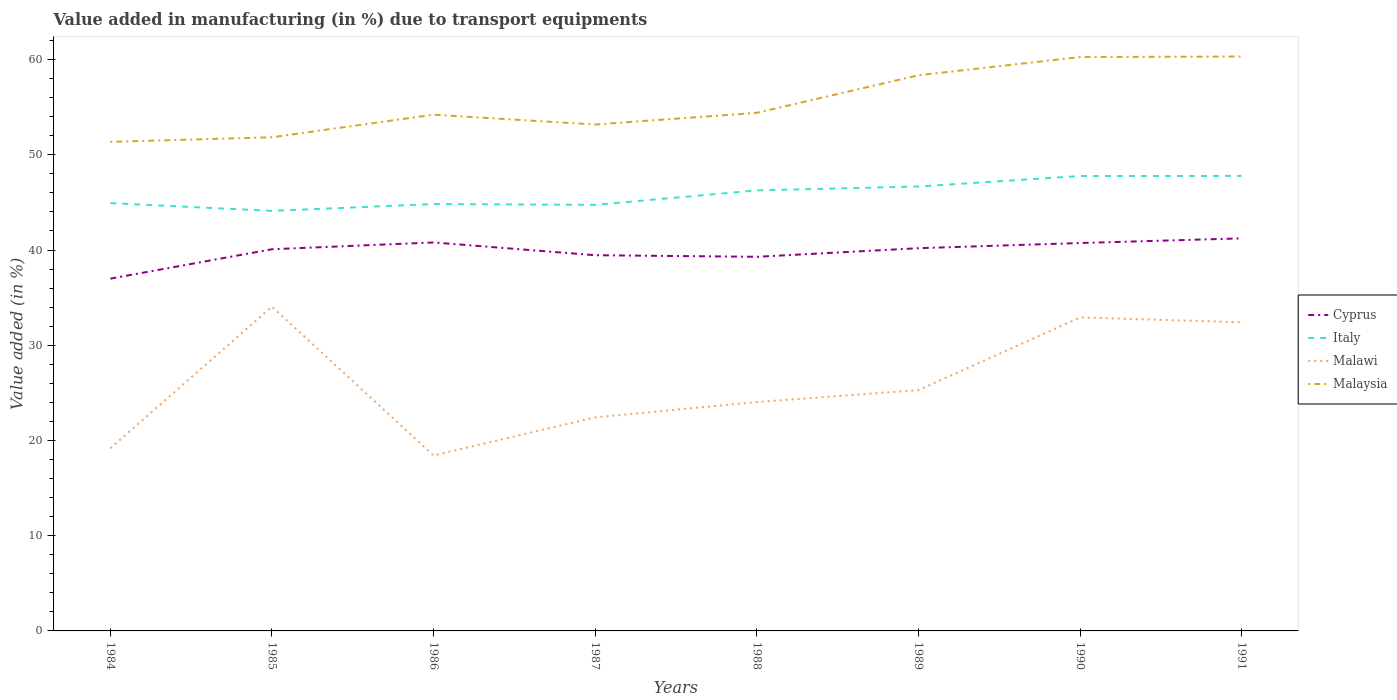How many different coloured lines are there?
Ensure brevity in your answer.  4. Does the line corresponding to Malawi intersect with the line corresponding to Italy?
Your response must be concise. No. Across all years, what is the maximum percentage of value added in manufacturing due to transport equipments in Malawi?
Make the answer very short. 18.42. What is the total percentage of value added in manufacturing due to transport equipments in Italy in the graph?
Ensure brevity in your answer.  -0.41. What is the difference between the highest and the second highest percentage of value added in manufacturing due to transport equipments in Italy?
Ensure brevity in your answer.  3.67. What is the difference between the highest and the lowest percentage of value added in manufacturing due to transport equipments in Malaysia?
Your answer should be very brief. 3. What is the difference between two consecutive major ticks on the Y-axis?
Provide a succinct answer. 10. Are the values on the major ticks of Y-axis written in scientific E-notation?
Make the answer very short. No. Does the graph contain any zero values?
Keep it short and to the point. No. Does the graph contain grids?
Make the answer very short. No. Where does the legend appear in the graph?
Offer a very short reply. Center right. How are the legend labels stacked?
Provide a succinct answer. Vertical. What is the title of the graph?
Ensure brevity in your answer.  Value added in manufacturing (in %) due to transport equipments. Does "Bangladesh" appear as one of the legend labels in the graph?
Offer a terse response. No. What is the label or title of the X-axis?
Your response must be concise. Years. What is the label or title of the Y-axis?
Your response must be concise. Value added (in %). What is the Value added (in %) of Cyprus in 1984?
Provide a short and direct response. 36.99. What is the Value added (in %) of Italy in 1984?
Offer a terse response. 44.93. What is the Value added (in %) of Malawi in 1984?
Keep it short and to the point. 19.17. What is the Value added (in %) of Malaysia in 1984?
Give a very brief answer. 51.36. What is the Value added (in %) in Cyprus in 1985?
Offer a terse response. 40.08. What is the Value added (in %) of Italy in 1985?
Your answer should be very brief. 44.11. What is the Value added (in %) of Malawi in 1985?
Provide a succinct answer. 34.05. What is the Value added (in %) of Malaysia in 1985?
Offer a very short reply. 51.84. What is the Value added (in %) in Cyprus in 1986?
Offer a terse response. 40.79. What is the Value added (in %) of Italy in 1986?
Provide a short and direct response. 44.83. What is the Value added (in %) in Malawi in 1986?
Provide a succinct answer. 18.42. What is the Value added (in %) of Malaysia in 1986?
Offer a terse response. 54.21. What is the Value added (in %) of Cyprus in 1987?
Your answer should be very brief. 39.45. What is the Value added (in %) in Italy in 1987?
Your answer should be compact. 44.74. What is the Value added (in %) of Malawi in 1987?
Provide a succinct answer. 22.43. What is the Value added (in %) of Malaysia in 1987?
Give a very brief answer. 53.18. What is the Value added (in %) in Cyprus in 1988?
Offer a terse response. 39.29. What is the Value added (in %) of Italy in 1988?
Offer a terse response. 46.26. What is the Value added (in %) of Malawi in 1988?
Provide a short and direct response. 24.04. What is the Value added (in %) in Malaysia in 1988?
Make the answer very short. 54.41. What is the Value added (in %) in Cyprus in 1989?
Your response must be concise. 40.19. What is the Value added (in %) of Italy in 1989?
Your response must be concise. 46.67. What is the Value added (in %) of Malawi in 1989?
Provide a succinct answer. 25.29. What is the Value added (in %) of Malaysia in 1989?
Provide a short and direct response. 58.35. What is the Value added (in %) of Cyprus in 1990?
Ensure brevity in your answer.  40.73. What is the Value added (in %) in Italy in 1990?
Ensure brevity in your answer.  47.77. What is the Value added (in %) of Malawi in 1990?
Your answer should be very brief. 32.92. What is the Value added (in %) in Malaysia in 1990?
Make the answer very short. 60.26. What is the Value added (in %) in Cyprus in 1991?
Provide a succinct answer. 41.22. What is the Value added (in %) of Italy in 1991?
Offer a terse response. 47.78. What is the Value added (in %) of Malawi in 1991?
Offer a terse response. 32.42. What is the Value added (in %) in Malaysia in 1991?
Provide a succinct answer. 60.32. Across all years, what is the maximum Value added (in %) of Cyprus?
Ensure brevity in your answer.  41.22. Across all years, what is the maximum Value added (in %) in Italy?
Provide a short and direct response. 47.78. Across all years, what is the maximum Value added (in %) in Malawi?
Provide a succinct answer. 34.05. Across all years, what is the maximum Value added (in %) in Malaysia?
Provide a succinct answer. 60.32. Across all years, what is the minimum Value added (in %) of Cyprus?
Your answer should be compact. 36.99. Across all years, what is the minimum Value added (in %) of Italy?
Provide a short and direct response. 44.11. Across all years, what is the minimum Value added (in %) of Malawi?
Keep it short and to the point. 18.42. Across all years, what is the minimum Value added (in %) of Malaysia?
Make the answer very short. 51.36. What is the total Value added (in %) in Cyprus in the graph?
Your answer should be very brief. 318.76. What is the total Value added (in %) of Italy in the graph?
Your answer should be very brief. 367.09. What is the total Value added (in %) in Malawi in the graph?
Provide a succinct answer. 208.73. What is the total Value added (in %) in Malaysia in the graph?
Your response must be concise. 443.93. What is the difference between the Value added (in %) in Cyprus in 1984 and that in 1985?
Keep it short and to the point. -3.09. What is the difference between the Value added (in %) in Italy in 1984 and that in 1985?
Ensure brevity in your answer.  0.82. What is the difference between the Value added (in %) in Malawi in 1984 and that in 1985?
Make the answer very short. -14.88. What is the difference between the Value added (in %) of Malaysia in 1984 and that in 1985?
Keep it short and to the point. -0.49. What is the difference between the Value added (in %) in Cyprus in 1984 and that in 1986?
Your response must be concise. -3.8. What is the difference between the Value added (in %) of Italy in 1984 and that in 1986?
Offer a terse response. 0.1. What is the difference between the Value added (in %) of Malawi in 1984 and that in 1986?
Ensure brevity in your answer.  0.75. What is the difference between the Value added (in %) of Malaysia in 1984 and that in 1986?
Your response must be concise. -2.85. What is the difference between the Value added (in %) in Cyprus in 1984 and that in 1987?
Your answer should be compact. -2.46. What is the difference between the Value added (in %) in Italy in 1984 and that in 1987?
Your response must be concise. 0.18. What is the difference between the Value added (in %) in Malawi in 1984 and that in 1987?
Provide a succinct answer. -3.25. What is the difference between the Value added (in %) of Malaysia in 1984 and that in 1987?
Provide a short and direct response. -1.82. What is the difference between the Value added (in %) of Cyprus in 1984 and that in 1988?
Give a very brief answer. -2.3. What is the difference between the Value added (in %) in Italy in 1984 and that in 1988?
Make the answer very short. -1.33. What is the difference between the Value added (in %) of Malawi in 1984 and that in 1988?
Your answer should be compact. -4.86. What is the difference between the Value added (in %) of Malaysia in 1984 and that in 1988?
Make the answer very short. -3.05. What is the difference between the Value added (in %) in Cyprus in 1984 and that in 1989?
Provide a short and direct response. -3.2. What is the difference between the Value added (in %) of Italy in 1984 and that in 1989?
Make the answer very short. -1.74. What is the difference between the Value added (in %) in Malawi in 1984 and that in 1989?
Provide a succinct answer. -6.11. What is the difference between the Value added (in %) of Malaysia in 1984 and that in 1989?
Your answer should be very brief. -6.99. What is the difference between the Value added (in %) in Cyprus in 1984 and that in 1990?
Provide a succinct answer. -3.74. What is the difference between the Value added (in %) of Italy in 1984 and that in 1990?
Ensure brevity in your answer.  -2.84. What is the difference between the Value added (in %) of Malawi in 1984 and that in 1990?
Your answer should be compact. -13.74. What is the difference between the Value added (in %) in Malaysia in 1984 and that in 1990?
Offer a terse response. -8.91. What is the difference between the Value added (in %) of Cyprus in 1984 and that in 1991?
Provide a succinct answer. -4.23. What is the difference between the Value added (in %) of Italy in 1984 and that in 1991?
Make the answer very short. -2.86. What is the difference between the Value added (in %) of Malawi in 1984 and that in 1991?
Offer a very short reply. -13.24. What is the difference between the Value added (in %) of Malaysia in 1984 and that in 1991?
Make the answer very short. -8.96. What is the difference between the Value added (in %) in Cyprus in 1985 and that in 1986?
Keep it short and to the point. -0.71. What is the difference between the Value added (in %) of Italy in 1985 and that in 1986?
Offer a very short reply. -0.72. What is the difference between the Value added (in %) in Malawi in 1985 and that in 1986?
Ensure brevity in your answer.  15.63. What is the difference between the Value added (in %) in Malaysia in 1985 and that in 1986?
Your response must be concise. -2.37. What is the difference between the Value added (in %) in Cyprus in 1985 and that in 1987?
Offer a very short reply. 0.63. What is the difference between the Value added (in %) in Italy in 1985 and that in 1987?
Provide a succinct answer. -0.63. What is the difference between the Value added (in %) of Malawi in 1985 and that in 1987?
Offer a terse response. 11.63. What is the difference between the Value added (in %) of Malaysia in 1985 and that in 1987?
Your answer should be compact. -1.34. What is the difference between the Value added (in %) in Cyprus in 1985 and that in 1988?
Your answer should be compact. 0.79. What is the difference between the Value added (in %) of Italy in 1985 and that in 1988?
Your answer should be very brief. -2.15. What is the difference between the Value added (in %) in Malawi in 1985 and that in 1988?
Give a very brief answer. 10.02. What is the difference between the Value added (in %) in Malaysia in 1985 and that in 1988?
Ensure brevity in your answer.  -2.57. What is the difference between the Value added (in %) in Cyprus in 1985 and that in 1989?
Keep it short and to the point. -0.11. What is the difference between the Value added (in %) of Italy in 1985 and that in 1989?
Provide a succinct answer. -2.56. What is the difference between the Value added (in %) of Malawi in 1985 and that in 1989?
Keep it short and to the point. 8.77. What is the difference between the Value added (in %) in Malaysia in 1985 and that in 1989?
Ensure brevity in your answer.  -6.51. What is the difference between the Value added (in %) of Cyprus in 1985 and that in 1990?
Provide a succinct answer. -0.65. What is the difference between the Value added (in %) in Italy in 1985 and that in 1990?
Provide a short and direct response. -3.66. What is the difference between the Value added (in %) in Malawi in 1985 and that in 1990?
Ensure brevity in your answer.  1.14. What is the difference between the Value added (in %) of Malaysia in 1985 and that in 1990?
Your answer should be compact. -8.42. What is the difference between the Value added (in %) in Cyprus in 1985 and that in 1991?
Keep it short and to the point. -1.14. What is the difference between the Value added (in %) of Italy in 1985 and that in 1991?
Provide a succinct answer. -3.67. What is the difference between the Value added (in %) of Malawi in 1985 and that in 1991?
Provide a short and direct response. 1.64. What is the difference between the Value added (in %) of Malaysia in 1985 and that in 1991?
Keep it short and to the point. -8.48. What is the difference between the Value added (in %) in Cyprus in 1986 and that in 1987?
Your answer should be compact. 1.34. What is the difference between the Value added (in %) of Italy in 1986 and that in 1987?
Make the answer very short. 0.08. What is the difference between the Value added (in %) in Malawi in 1986 and that in 1987?
Offer a very short reply. -4. What is the difference between the Value added (in %) in Malaysia in 1986 and that in 1987?
Provide a succinct answer. 1.03. What is the difference between the Value added (in %) in Cyprus in 1986 and that in 1988?
Offer a very short reply. 1.51. What is the difference between the Value added (in %) in Italy in 1986 and that in 1988?
Your answer should be very brief. -1.43. What is the difference between the Value added (in %) in Malawi in 1986 and that in 1988?
Ensure brevity in your answer.  -5.61. What is the difference between the Value added (in %) in Malaysia in 1986 and that in 1988?
Your response must be concise. -0.2. What is the difference between the Value added (in %) of Cyprus in 1986 and that in 1989?
Keep it short and to the point. 0.6. What is the difference between the Value added (in %) in Italy in 1986 and that in 1989?
Your response must be concise. -1.84. What is the difference between the Value added (in %) of Malawi in 1986 and that in 1989?
Offer a very short reply. -6.86. What is the difference between the Value added (in %) of Malaysia in 1986 and that in 1989?
Your answer should be very brief. -4.14. What is the difference between the Value added (in %) of Cyprus in 1986 and that in 1990?
Offer a very short reply. 0.06. What is the difference between the Value added (in %) in Italy in 1986 and that in 1990?
Keep it short and to the point. -2.94. What is the difference between the Value added (in %) of Malawi in 1986 and that in 1990?
Give a very brief answer. -14.49. What is the difference between the Value added (in %) of Malaysia in 1986 and that in 1990?
Provide a short and direct response. -6.05. What is the difference between the Value added (in %) in Cyprus in 1986 and that in 1991?
Offer a very short reply. -0.43. What is the difference between the Value added (in %) in Italy in 1986 and that in 1991?
Provide a short and direct response. -2.96. What is the difference between the Value added (in %) of Malawi in 1986 and that in 1991?
Your answer should be compact. -13.99. What is the difference between the Value added (in %) of Malaysia in 1986 and that in 1991?
Offer a terse response. -6.11. What is the difference between the Value added (in %) in Cyprus in 1987 and that in 1988?
Offer a very short reply. 0.17. What is the difference between the Value added (in %) in Italy in 1987 and that in 1988?
Your response must be concise. -1.52. What is the difference between the Value added (in %) in Malawi in 1987 and that in 1988?
Make the answer very short. -1.61. What is the difference between the Value added (in %) in Malaysia in 1987 and that in 1988?
Keep it short and to the point. -1.23. What is the difference between the Value added (in %) of Cyprus in 1987 and that in 1989?
Offer a terse response. -0.74. What is the difference between the Value added (in %) of Italy in 1987 and that in 1989?
Ensure brevity in your answer.  -1.93. What is the difference between the Value added (in %) of Malawi in 1987 and that in 1989?
Ensure brevity in your answer.  -2.86. What is the difference between the Value added (in %) of Malaysia in 1987 and that in 1989?
Keep it short and to the point. -5.17. What is the difference between the Value added (in %) of Cyprus in 1987 and that in 1990?
Provide a short and direct response. -1.28. What is the difference between the Value added (in %) of Italy in 1987 and that in 1990?
Give a very brief answer. -3.02. What is the difference between the Value added (in %) of Malawi in 1987 and that in 1990?
Offer a terse response. -10.49. What is the difference between the Value added (in %) in Malaysia in 1987 and that in 1990?
Ensure brevity in your answer.  -7.09. What is the difference between the Value added (in %) of Cyprus in 1987 and that in 1991?
Offer a terse response. -1.77. What is the difference between the Value added (in %) of Italy in 1987 and that in 1991?
Provide a short and direct response. -3.04. What is the difference between the Value added (in %) in Malawi in 1987 and that in 1991?
Keep it short and to the point. -9.99. What is the difference between the Value added (in %) of Malaysia in 1987 and that in 1991?
Keep it short and to the point. -7.14. What is the difference between the Value added (in %) in Cyprus in 1988 and that in 1989?
Your response must be concise. -0.9. What is the difference between the Value added (in %) in Italy in 1988 and that in 1989?
Offer a very short reply. -0.41. What is the difference between the Value added (in %) of Malawi in 1988 and that in 1989?
Your answer should be very brief. -1.25. What is the difference between the Value added (in %) of Malaysia in 1988 and that in 1989?
Make the answer very short. -3.94. What is the difference between the Value added (in %) in Cyprus in 1988 and that in 1990?
Offer a terse response. -1.45. What is the difference between the Value added (in %) in Italy in 1988 and that in 1990?
Provide a short and direct response. -1.51. What is the difference between the Value added (in %) of Malawi in 1988 and that in 1990?
Ensure brevity in your answer.  -8.88. What is the difference between the Value added (in %) of Malaysia in 1988 and that in 1990?
Provide a succinct answer. -5.86. What is the difference between the Value added (in %) of Cyprus in 1988 and that in 1991?
Provide a succinct answer. -1.93. What is the difference between the Value added (in %) in Italy in 1988 and that in 1991?
Your answer should be compact. -1.52. What is the difference between the Value added (in %) in Malawi in 1988 and that in 1991?
Offer a very short reply. -8.38. What is the difference between the Value added (in %) in Malaysia in 1988 and that in 1991?
Provide a succinct answer. -5.91. What is the difference between the Value added (in %) in Cyprus in 1989 and that in 1990?
Ensure brevity in your answer.  -0.54. What is the difference between the Value added (in %) of Italy in 1989 and that in 1990?
Ensure brevity in your answer.  -1.1. What is the difference between the Value added (in %) of Malawi in 1989 and that in 1990?
Provide a succinct answer. -7.63. What is the difference between the Value added (in %) of Malaysia in 1989 and that in 1990?
Your response must be concise. -1.91. What is the difference between the Value added (in %) of Cyprus in 1989 and that in 1991?
Ensure brevity in your answer.  -1.03. What is the difference between the Value added (in %) in Italy in 1989 and that in 1991?
Offer a very short reply. -1.12. What is the difference between the Value added (in %) in Malawi in 1989 and that in 1991?
Provide a succinct answer. -7.13. What is the difference between the Value added (in %) of Malaysia in 1989 and that in 1991?
Your answer should be compact. -1.97. What is the difference between the Value added (in %) in Cyprus in 1990 and that in 1991?
Provide a short and direct response. -0.49. What is the difference between the Value added (in %) in Italy in 1990 and that in 1991?
Provide a short and direct response. -0.02. What is the difference between the Value added (in %) in Malawi in 1990 and that in 1991?
Ensure brevity in your answer.  0.5. What is the difference between the Value added (in %) in Malaysia in 1990 and that in 1991?
Make the answer very short. -0.06. What is the difference between the Value added (in %) of Cyprus in 1984 and the Value added (in %) of Italy in 1985?
Offer a very short reply. -7.12. What is the difference between the Value added (in %) of Cyprus in 1984 and the Value added (in %) of Malawi in 1985?
Provide a short and direct response. 2.94. What is the difference between the Value added (in %) of Cyprus in 1984 and the Value added (in %) of Malaysia in 1985?
Your response must be concise. -14.85. What is the difference between the Value added (in %) of Italy in 1984 and the Value added (in %) of Malawi in 1985?
Provide a succinct answer. 10.87. What is the difference between the Value added (in %) of Italy in 1984 and the Value added (in %) of Malaysia in 1985?
Keep it short and to the point. -6.91. What is the difference between the Value added (in %) in Malawi in 1984 and the Value added (in %) in Malaysia in 1985?
Give a very brief answer. -32.67. What is the difference between the Value added (in %) in Cyprus in 1984 and the Value added (in %) in Italy in 1986?
Ensure brevity in your answer.  -7.84. What is the difference between the Value added (in %) of Cyprus in 1984 and the Value added (in %) of Malawi in 1986?
Keep it short and to the point. 18.57. What is the difference between the Value added (in %) of Cyprus in 1984 and the Value added (in %) of Malaysia in 1986?
Provide a succinct answer. -17.22. What is the difference between the Value added (in %) in Italy in 1984 and the Value added (in %) in Malawi in 1986?
Provide a succinct answer. 26.5. What is the difference between the Value added (in %) of Italy in 1984 and the Value added (in %) of Malaysia in 1986?
Make the answer very short. -9.28. What is the difference between the Value added (in %) of Malawi in 1984 and the Value added (in %) of Malaysia in 1986?
Provide a short and direct response. -35.04. What is the difference between the Value added (in %) of Cyprus in 1984 and the Value added (in %) of Italy in 1987?
Offer a very short reply. -7.75. What is the difference between the Value added (in %) of Cyprus in 1984 and the Value added (in %) of Malawi in 1987?
Provide a succinct answer. 14.57. What is the difference between the Value added (in %) of Cyprus in 1984 and the Value added (in %) of Malaysia in 1987?
Keep it short and to the point. -16.18. What is the difference between the Value added (in %) in Italy in 1984 and the Value added (in %) in Malawi in 1987?
Your answer should be very brief. 22.5. What is the difference between the Value added (in %) in Italy in 1984 and the Value added (in %) in Malaysia in 1987?
Your answer should be very brief. -8.25. What is the difference between the Value added (in %) in Malawi in 1984 and the Value added (in %) in Malaysia in 1987?
Provide a short and direct response. -34. What is the difference between the Value added (in %) of Cyprus in 1984 and the Value added (in %) of Italy in 1988?
Your answer should be compact. -9.27. What is the difference between the Value added (in %) in Cyprus in 1984 and the Value added (in %) in Malawi in 1988?
Your response must be concise. 12.95. What is the difference between the Value added (in %) of Cyprus in 1984 and the Value added (in %) of Malaysia in 1988?
Provide a short and direct response. -17.42. What is the difference between the Value added (in %) in Italy in 1984 and the Value added (in %) in Malawi in 1988?
Offer a terse response. 20.89. What is the difference between the Value added (in %) of Italy in 1984 and the Value added (in %) of Malaysia in 1988?
Your answer should be compact. -9.48. What is the difference between the Value added (in %) in Malawi in 1984 and the Value added (in %) in Malaysia in 1988?
Give a very brief answer. -35.23. What is the difference between the Value added (in %) in Cyprus in 1984 and the Value added (in %) in Italy in 1989?
Your answer should be compact. -9.68. What is the difference between the Value added (in %) of Cyprus in 1984 and the Value added (in %) of Malawi in 1989?
Give a very brief answer. 11.7. What is the difference between the Value added (in %) in Cyprus in 1984 and the Value added (in %) in Malaysia in 1989?
Provide a succinct answer. -21.36. What is the difference between the Value added (in %) of Italy in 1984 and the Value added (in %) of Malawi in 1989?
Your response must be concise. 19.64. What is the difference between the Value added (in %) in Italy in 1984 and the Value added (in %) in Malaysia in 1989?
Your response must be concise. -13.42. What is the difference between the Value added (in %) of Malawi in 1984 and the Value added (in %) of Malaysia in 1989?
Offer a terse response. -39.18. What is the difference between the Value added (in %) in Cyprus in 1984 and the Value added (in %) in Italy in 1990?
Your response must be concise. -10.78. What is the difference between the Value added (in %) in Cyprus in 1984 and the Value added (in %) in Malawi in 1990?
Offer a terse response. 4.08. What is the difference between the Value added (in %) of Cyprus in 1984 and the Value added (in %) of Malaysia in 1990?
Your response must be concise. -23.27. What is the difference between the Value added (in %) in Italy in 1984 and the Value added (in %) in Malawi in 1990?
Provide a short and direct response. 12.01. What is the difference between the Value added (in %) in Italy in 1984 and the Value added (in %) in Malaysia in 1990?
Ensure brevity in your answer.  -15.34. What is the difference between the Value added (in %) of Malawi in 1984 and the Value added (in %) of Malaysia in 1990?
Make the answer very short. -41.09. What is the difference between the Value added (in %) in Cyprus in 1984 and the Value added (in %) in Italy in 1991?
Keep it short and to the point. -10.79. What is the difference between the Value added (in %) of Cyprus in 1984 and the Value added (in %) of Malawi in 1991?
Make the answer very short. 4.58. What is the difference between the Value added (in %) in Cyprus in 1984 and the Value added (in %) in Malaysia in 1991?
Provide a succinct answer. -23.33. What is the difference between the Value added (in %) of Italy in 1984 and the Value added (in %) of Malawi in 1991?
Your answer should be compact. 12.51. What is the difference between the Value added (in %) of Italy in 1984 and the Value added (in %) of Malaysia in 1991?
Offer a terse response. -15.39. What is the difference between the Value added (in %) in Malawi in 1984 and the Value added (in %) in Malaysia in 1991?
Your answer should be compact. -41.15. What is the difference between the Value added (in %) in Cyprus in 1985 and the Value added (in %) in Italy in 1986?
Offer a terse response. -4.75. What is the difference between the Value added (in %) in Cyprus in 1985 and the Value added (in %) in Malawi in 1986?
Make the answer very short. 21.66. What is the difference between the Value added (in %) in Cyprus in 1985 and the Value added (in %) in Malaysia in 1986?
Offer a very short reply. -14.13. What is the difference between the Value added (in %) in Italy in 1985 and the Value added (in %) in Malawi in 1986?
Provide a short and direct response. 25.69. What is the difference between the Value added (in %) in Italy in 1985 and the Value added (in %) in Malaysia in 1986?
Your answer should be very brief. -10.1. What is the difference between the Value added (in %) of Malawi in 1985 and the Value added (in %) of Malaysia in 1986?
Make the answer very short. -20.16. What is the difference between the Value added (in %) of Cyprus in 1985 and the Value added (in %) of Italy in 1987?
Offer a very short reply. -4.66. What is the difference between the Value added (in %) of Cyprus in 1985 and the Value added (in %) of Malawi in 1987?
Ensure brevity in your answer.  17.65. What is the difference between the Value added (in %) in Cyprus in 1985 and the Value added (in %) in Malaysia in 1987?
Provide a short and direct response. -13.1. What is the difference between the Value added (in %) of Italy in 1985 and the Value added (in %) of Malawi in 1987?
Your response must be concise. 21.68. What is the difference between the Value added (in %) in Italy in 1985 and the Value added (in %) in Malaysia in 1987?
Offer a very short reply. -9.07. What is the difference between the Value added (in %) in Malawi in 1985 and the Value added (in %) in Malaysia in 1987?
Make the answer very short. -19.12. What is the difference between the Value added (in %) in Cyprus in 1985 and the Value added (in %) in Italy in 1988?
Your answer should be compact. -6.18. What is the difference between the Value added (in %) of Cyprus in 1985 and the Value added (in %) of Malawi in 1988?
Give a very brief answer. 16.04. What is the difference between the Value added (in %) of Cyprus in 1985 and the Value added (in %) of Malaysia in 1988?
Make the answer very short. -14.33. What is the difference between the Value added (in %) in Italy in 1985 and the Value added (in %) in Malawi in 1988?
Provide a short and direct response. 20.07. What is the difference between the Value added (in %) of Italy in 1985 and the Value added (in %) of Malaysia in 1988?
Offer a terse response. -10.3. What is the difference between the Value added (in %) in Malawi in 1985 and the Value added (in %) in Malaysia in 1988?
Ensure brevity in your answer.  -20.35. What is the difference between the Value added (in %) of Cyprus in 1985 and the Value added (in %) of Italy in 1989?
Your answer should be compact. -6.59. What is the difference between the Value added (in %) in Cyprus in 1985 and the Value added (in %) in Malawi in 1989?
Give a very brief answer. 14.79. What is the difference between the Value added (in %) of Cyprus in 1985 and the Value added (in %) of Malaysia in 1989?
Keep it short and to the point. -18.27. What is the difference between the Value added (in %) in Italy in 1985 and the Value added (in %) in Malawi in 1989?
Ensure brevity in your answer.  18.82. What is the difference between the Value added (in %) of Italy in 1985 and the Value added (in %) of Malaysia in 1989?
Ensure brevity in your answer.  -14.24. What is the difference between the Value added (in %) in Malawi in 1985 and the Value added (in %) in Malaysia in 1989?
Keep it short and to the point. -24.3. What is the difference between the Value added (in %) of Cyprus in 1985 and the Value added (in %) of Italy in 1990?
Your answer should be very brief. -7.69. What is the difference between the Value added (in %) in Cyprus in 1985 and the Value added (in %) in Malawi in 1990?
Your answer should be compact. 7.17. What is the difference between the Value added (in %) in Cyprus in 1985 and the Value added (in %) in Malaysia in 1990?
Keep it short and to the point. -20.18. What is the difference between the Value added (in %) in Italy in 1985 and the Value added (in %) in Malawi in 1990?
Provide a succinct answer. 11.2. What is the difference between the Value added (in %) of Italy in 1985 and the Value added (in %) of Malaysia in 1990?
Provide a short and direct response. -16.15. What is the difference between the Value added (in %) in Malawi in 1985 and the Value added (in %) in Malaysia in 1990?
Give a very brief answer. -26.21. What is the difference between the Value added (in %) of Cyprus in 1985 and the Value added (in %) of Italy in 1991?
Make the answer very short. -7.7. What is the difference between the Value added (in %) of Cyprus in 1985 and the Value added (in %) of Malawi in 1991?
Your answer should be very brief. 7.67. What is the difference between the Value added (in %) in Cyprus in 1985 and the Value added (in %) in Malaysia in 1991?
Your response must be concise. -20.24. What is the difference between the Value added (in %) of Italy in 1985 and the Value added (in %) of Malawi in 1991?
Your answer should be very brief. 11.7. What is the difference between the Value added (in %) of Italy in 1985 and the Value added (in %) of Malaysia in 1991?
Your answer should be very brief. -16.21. What is the difference between the Value added (in %) in Malawi in 1985 and the Value added (in %) in Malaysia in 1991?
Your answer should be very brief. -26.27. What is the difference between the Value added (in %) of Cyprus in 1986 and the Value added (in %) of Italy in 1987?
Your answer should be very brief. -3.95. What is the difference between the Value added (in %) in Cyprus in 1986 and the Value added (in %) in Malawi in 1987?
Your response must be concise. 18.37. What is the difference between the Value added (in %) in Cyprus in 1986 and the Value added (in %) in Malaysia in 1987?
Provide a succinct answer. -12.38. What is the difference between the Value added (in %) in Italy in 1986 and the Value added (in %) in Malawi in 1987?
Offer a terse response. 22.4. What is the difference between the Value added (in %) of Italy in 1986 and the Value added (in %) of Malaysia in 1987?
Provide a short and direct response. -8.35. What is the difference between the Value added (in %) in Malawi in 1986 and the Value added (in %) in Malaysia in 1987?
Ensure brevity in your answer.  -34.75. What is the difference between the Value added (in %) in Cyprus in 1986 and the Value added (in %) in Italy in 1988?
Offer a very short reply. -5.47. What is the difference between the Value added (in %) of Cyprus in 1986 and the Value added (in %) of Malawi in 1988?
Your answer should be very brief. 16.76. What is the difference between the Value added (in %) of Cyprus in 1986 and the Value added (in %) of Malaysia in 1988?
Give a very brief answer. -13.61. What is the difference between the Value added (in %) of Italy in 1986 and the Value added (in %) of Malawi in 1988?
Offer a very short reply. 20.79. What is the difference between the Value added (in %) of Italy in 1986 and the Value added (in %) of Malaysia in 1988?
Provide a short and direct response. -9.58. What is the difference between the Value added (in %) in Malawi in 1986 and the Value added (in %) in Malaysia in 1988?
Your response must be concise. -35.98. What is the difference between the Value added (in %) in Cyprus in 1986 and the Value added (in %) in Italy in 1989?
Make the answer very short. -5.87. What is the difference between the Value added (in %) in Cyprus in 1986 and the Value added (in %) in Malawi in 1989?
Your answer should be very brief. 15.51. What is the difference between the Value added (in %) in Cyprus in 1986 and the Value added (in %) in Malaysia in 1989?
Ensure brevity in your answer.  -17.56. What is the difference between the Value added (in %) in Italy in 1986 and the Value added (in %) in Malawi in 1989?
Ensure brevity in your answer.  19.54. What is the difference between the Value added (in %) of Italy in 1986 and the Value added (in %) of Malaysia in 1989?
Your answer should be very brief. -13.52. What is the difference between the Value added (in %) of Malawi in 1986 and the Value added (in %) of Malaysia in 1989?
Your answer should be compact. -39.93. What is the difference between the Value added (in %) in Cyprus in 1986 and the Value added (in %) in Italy in 1990?
Your answer should be compact. -6.97. What is the difference between the Value added (in %) of Cyprus in 1986 and the Value added (in %) of Malawi in 1990?
Your response must be concise. 7.88. What is the difference between the Value added (in %) of Cyprus in 1986 and the Value added (in %) of Malaysia in 1990?
Give a very brief answer. -19.47. What is the difference between the Value added (in %) of Italy in 1986 and the Value added (in %) of Malawi in 1990?
Provide a succinct answer. 11.91. What is the difference between the Value added (in %) of Italy in 1986 and the Value added (in %) of Malaysia in 1990?
Your response must be concise. -15.44. What is the difference between the Value added (in %) of Malawi in 1986 and the Value added (in %) of Malaysia in 1990?
Provide a short and direct response. -41.84. What is the difference between the Value added (in %) of Cyprus in 1986 and the Value added (in %) of Italy in 1991?
Keep it short and to the point. -6.99. What is the difference between the Value added (in %) in Cyprus in 1986 and the Value added (in %) in Malawi in 1991?
Offer a terse response. 8.38. What is the difference between the Value added (in %) of Cyprus in 1986 and the Value added (in %) of Malaysia in 1991?
Make the answer very short. -19.52. What is the difference between the Value added (in %) of Italy in 1986 and the Value added (in %) of Malawi in 1991?
Offer a very short reply. 12.41. What is the difference between the Value added (in %) in Italy in 1986 and the Value added (in %) in Malaysia in 1991?
Offer a terse response. -15.49. What is the difference between the Value added (in %) of Malawi in 1986 and the Value added (in %) of Malaysia in 1991?
Offer a terse response. -41.9. What is the difference between the Value added (in %) in Cyprus in 1987 and the Value added (in %) in Italy in 1988?
Offer a terse response. -6.81. What is the difference between the Value added (in %) of Cyprus in 1987 and the Value added (in %) of Malawi in 1988?
Your response must be concise. 15.42. What is the difference between the Value added (in %) in Cyprus in 1987 and the Value added (in %) in Malaysia in 1988?
Your answer should be compact. -14.95. What is the difference between the Value added (in %) of Italy in 1987 and the Value added (in %) of Malawi in 1988?
Provide a short and direct response. 20.71. What is the difference between the Value added (in %) of Italy in 1987 and the Value added (in %) of Malaysia in 1988?
Offer a terse response. -9.66. What is the difference between the Value added (in %) in Malawi in 1987 and the Value added (in %) in Malaysia in 1988?
Provide a succinct answer. -31.98. What is the difference between the Value added (in %) in Cyprus in 1987 and the Value added (in %) in Italy in 1989?
Provide a short and direct response. -7.22. What is the difference between the Value added (in %) of Cyprus in 1987 and the Value added (in %) of Malawi in 1989?
Give a very brief answer. 14.17. What is the difference between the Value added (in %) in Cyprus in 1987 and the Value added (in %) in Malaysia in 1989?
Your answer should be very brief. -18.9. What is the difference between the Value added (in %) in Italy in 1987 and the Value added (in %) in Malawi in 1989?
Your answer should be very brief. 19.46. What is the difference between the Value added (in %) of Italy in 1987 and the Value added (in %) of Malaysia in 1989?
Your answer should be very brief. -13.61. What is the difference between the Value added (in %) in Malawi in 1987 and the Value added (in %) in Malaysia in 1989?
Provide a succinct answer. -35.93. What is the difference between the Value added (in %) of Cyprus in 1987 and the Value added (in %) of Italy in 1990?
Your answer should be very brief. -8.31. What is the difference between the Value added (in %) in Cyprus in 1987 and the Value added (in %) in Malawi in 1990?
Ensure brevity in your answer.  6.54. What is the difference between the Value added (in %) of Cyprus in 1987 and the Value added (in %) of Malaysia in 1990?
Your response must be concise. -20.81. What is the difference between the Value added (in %) in Italy in 1987 and the Value added (in %) in Malawi in 1990?
Provide a succinct answer. 11.83. What is the difference between the Value added (in %) of Italy in 1987 and the Value added (in %) of Malaysia in 1990?
Give a very brief answer. -15.52. What is the difference between the Value added (in %) in Malawi in 1987 and the Value added (in %) in Malaysia in 1990?
Provide a succinct answer. -37.84. What is the difference between the Value added (in %) of Cyprus in 1987 and the Value added (in %) of Italy in 1991?
Offer a terse response. -8.33. What is the difference between the Value added (in %) in Cyprus in 1987 and the Value added (in %) in Malawi in 1991?
Give a very brief answer. 7.04. What is the difference between the Value added (in %) in Cyprus in 1987 and the Value added (in %) in Malaysia in 1991?
Offer a very short reply. -20.87. What is the difference between the Value added (in %) of Italy in 1987 and the Value added (in %) of Malawi in 1991?
Offer a very short reply. 12.33. What is the difference between the Value added (in %) of Italy in 1987 and the Value added (in %) of Malaysia in 1991?
Give a very brief answer. -15.58. What is the difference between the Value added (in %) in Malawi in 1987 and the Value added (in %) in Malaysia in 1991?
Ensure brevity in your answer.  -37.89. What is the difference between the Value added (in %) of Cyprus in 1988 and the Value added (in %) of Italy in 1989?
Give a very brief answer. -7.38. What is the difference between the Value added (in %) of Cyprus in 1988 and the Value added (in %) of Malawi in 1989?
Ensure brevity in your answer.  14. What is the difference between the Value added (in %) in Cyprus in 1988 and the Value added (in %) in Malaysia in 1989?
Give a very brief answer. -19.06. What is the difference between the Value added (in %) in Italy in 1988 and the Value added (in %) in Malawi in 1989?
Provide a short and direct response. 20.97. What is the difference between the Value added (in %) in Italy in 1988 and the Value added (in %) in Malaysia in 1989?
Your response must be concise. -12.09. What is the difference between the Value added (in %) of Malawi in 1988 and the Value added (in %) of Malaysia in 1989?
Offer a very short reply. -34.31. What is the difference between the Value added (in %) in Cyprus in 1988 and the Value added (in %) in Italy in 1990?
Offer a terse response. -8.48. What is the difference between the Value added (in %) of Cyprus in 1988 and the Value added (in %) of Malawi in 1990?
Your answer should be very brief. 6.37. What is the difference between the Value added (in %) in Cyprus in 1988 and the Value added (in %) in Malaysia in 1990?
Your answer should be very brief. -20.98. What is the difference between the Value added (in %) of Italy in 1988 and the Value added (in %) of Malawi in 1990?
Provide a short and direct response. 13.35. What is the difference between the Value added (in %) in Italy in 1988 and the Value added (in %) in Malaysia in 1990?
Your answer should be compact. -14. What is the difference between the Value added (in %) of Malawi in 1988 and the Value added (in %) of Malaysia in 1990?
Keep it short and to the point. -36.23. What is the difference between the Value added (in %) of Cyprus in 1988 and the Value added (in %) of Italy in 1991?
Offer a very short reply. -8.5. What is the difference between the Value added (in %) of Cyprus in 1988 and the Value added (in %) of Malawi in 1991?
Offer a terse response. 6.87. What is the difference between the Value added (in %) in Cyprus in 1988 and the Value added (in %) in Malaysia in 1991?
Ensure brevity in your answer.  -21.03. What is the difference between the Value added (in %) of Italy in 1988 and the Value added (in %) of Malawi in 1991?
Provide a succinct answer. 13.85. What is the difference between the Value added (in %) of Italy in 1988 and the Value added (in %) of Malaysia in 1991?
Keep it short and to the point. -14.06. What is the difference between the Value added (in %) of Malawi in 1988 and the Value added (in %) of Malaysia in 1991?
Offer a very short reply. -36.28. What is the difference between the Value added (in %) in Cyprus in 1989 and the Value added (in %) in Italy in 1990?
Your response must be concise. -7.58. What is the difference between the Value added (in %) in Cyprus in 1989 and the Value added (in %) in Malawi in 1990?
Keep it short and to the point. 7.28. What is the difference between the Value added (in %) in Cyprus in 1989 and the Value added (in %) in Malaysia in 1990?
Offer a very short reply. -20.07. What is the difference between the Value added (in %) in Italy in 1989 and the Value added (in %) in Malawi in 1990?
Make the answer very short. 13.75. What is the difference between the Value added (in %) in Italy in 1989 and the Value added (in %) in Malaysia in 1990?
Provide a succinct answer. -13.59. What is the difference between the Value added (in %) of Malawi in 1989 and the Value added (in %) of Malaysia in 1990?
Provide a short and direct response. -34.98. What is the difference between the Value added (in %) of Cyprus in 1989 and the Value added (in %) of Italy in 1991?
Provide a short and direct response. -7.59. What is the difference between the Value added (in %) of Cyprus in 1989 and the Value added (in %) of Malawi in 1991?
Provide a succinct answer. 7.78. What is the difference between the Value added (in %) of Cyprus in 1989 and the Value added (in %) of Malaysia in 1991?
Offer a terse response. -20.13. What is the difference between the Value added (in %) of Italy in 1989 and the Value added (in %) of Malawi in 1991?
Your answer should be compact. 14.25. What is the difference between the Value added (in %) in Italy in 1989 and the Value added (in %) in Malaysia in 1991?
Your response must be concise. -13.65. What is the difference between the Value added (in %) in Malawi in 1989 and the Value added (in %) in Malaysia in 1991?
Your answer should be compact. -35.03. What is the difference between the Value added (in %) of Cyprus in 1990 and the Value added (in %) of Italy in 1991?
Ensure brevity in your answer.  -7.05. What is the difference between the Value added (in %) of Cyprus in 1990 and the Value added (in %) of Malawi in 1991?
Provide a succinct answer. 8.32. What is the difference between the Value added (in %) in Cyprus in 1990 and the Value added (in %) in Malaysia in 1991?
Give a very brief answer. -19.58. What is the difference between the Value added (in %) in Italy in 1990 and the Value added (in %) in Malawi in 1991?
Your answer should be compact. 15.35. What is the difference between the Value added (in %) of Italy in 1990 and the Value added (in %) of Malaysia in 1991?
Ensure brevity in your answer.  -12.55. What is the difference between the Value added (in %) in Malawi in 1990 and the Value added (in %) in Malaysia in 1991?
Provide a succinct answer. -27.4. What is the average Value added (in %) of Cyprus per year?
Provide a short and direct response. 39.84. What is the average Value added (in %) in Italy per year?
Your answer should be compact. 45.89. What is the average Value added (in %) in Malawi per year?
Your answer should be compact. 26.09. What is the average Value added (in %) in Malaysia per year?
Keep it short and to the point. 55.49. In the year 1984, what is the difference between the Value added (in %) of Cyprus and Value added (in %) of Italy?
Give a very brief answer. -7.94. In the year 1984, what is the difference between the Value added (in %) in Cyprus and Value added (in %) in Malawi?
Give a very brief answer. 17.82. In the year 1984, what is the difference between the Value added (in %) of Cyprus and Value added (in %) of Malaysia?
Offer a terse response. -14.36. In the year 1984, what is the difference between the Value added (in %) of Italy and Value added (in %) of Malawi?
Your answer should be very brief. 25.75. In the year 1984, what is the difference between the Value added (in %) of Italy and Value added (in %) of Malaysia?
Your response must be concise. -6.43. In the year 1984, what is the difference between the Value added (in %) of Malawi and Value added (in %) of Malaysia?
Your answer should be very brief. -32.18. In the year 1985, what is the difference between the Value added (in %) of Cyprus and Value added (in %) of Italy?
Offer a terse response. -4.03. In the year 1985, what is the difference between the Value added (in %) in Cyprus and Value added (in %) in Malawi?
Make the answer very short. 6.03. In the year 1985, what is the difference between the Value added (in %) of Cyprus and Value added (in %) of Malaysia?
Keep it short and to the point. -11.76. In the year 1985, what is the difference between the Value added (in %) of Italy and Value added (in %) of Malawi?
Offer a terse response. 10.06. In the year 1985, what is the difference between the Value added (in %) in Italy and Value added (in %) in Malaysia?
Your answer should be compact. -7.73. In the year 1985, what is the difference between the Value added (in %) in Malawi and Value added (in %) in Malaysia?
Offer a terse response. -17.79. In the year 1986, what is the difference between the Value added (in %) of Cyprus and Value added (in %) of Italy?
Offer a very short reply. -4.03. In the year 1986, what is the difference between the Value added (in %) in Cyprus and Value added (in %) in Malawi?
Your answer should be compact. 22.37. In the year 1986, what is the difference between the Value added (in %) in Cyprus and Value added (in %) in Malaysia?
Make the answer very short. -13.42. In the year 1986, what is the difference between the Value added (in %) of Italy and Value added (in %) of Malawi?
Your answer should be compact. 26.4. In the year 1986, what is the difference between the Value added (in %) in Italy and Value added (in %) in Malaysia?
Provide a succinct answer. -9.38. In the year 1986, what is the difference between the Value added (in %) in Malawi and Value added (in %) in Malaysia?
Make the answer very short. -35.79. In the year 1987, what is the difference between the Value added (in %) in Cyprus and Value added (in %) in Italy?
Offer a terse response. -5.29. In the year 1987, what is the difference between the Value added (in %) in Cyprus and Value added (in %) in Malawi?
Give a very brief answer. 17.03. In the year 1987, what is the difference between the Value added (in %) in Cyprus and Value added (in %) in Malaysia?
Offer a terse response. -13.72. In the year 1987, what is the difference between the Value added (in %) in Italy and Value added (in %) in Malawi?
Offer a terse response. 22.32. In the year 1987, what is the difference between the Value added (in %) of Italy and Value added (in %) of Malaysia?
Give a very brief answer. -8.43. In the year 1987, what is the difference between the Value added (in %) of Malawi and Value added (in %) of Malaysia?
Offer a terse response. -30.75. In the year 1988, what is the difference between the Value added (in %) of Cyprus and Value added (in %) of Italy?
Your answer should be compact. -6.97. In the year 1988, what is the difference between the Value added (in %) of Cyprus and Value added (in %) of Malawi?
Your answer should be compact. 15.25. In the year 1988, what is the difference between the Value added (in %) of Cyprus and Value added (in %) of Malaysia?
Offer a very short reply. -15.12. In the year 1988, what is the difference between the Value added (in %) in Italy and Value added (in %) in Malawi?
Your answer should be very brief. 22.22. In the year 1988, what is the difference between the Value added (in %) in Italy and Value added (in %) in Malaysia?
Offer a very short reply. -8.15. In the year 1988, what is the difference between the Value added (in %) of Malawi and Value added (in %) of Malaysia?
Provide a succinct answer. -30.37. In the year 1989, what is the difference between the Value added (in %) in Cyprus and Value added (in %) in Italy?
Keep it short and to the point. -6.48. In the year 1989, what is the difference between the Value added (in %) of Cyprus and Value added (in %) of Malawi?
Your response must be concise. 14.9. In the year 1989, what is the difference between the Value added (in %) of Cyprus and Value added (in %) of Malaysia?
Provide a succinct answer. -18.16. In the year 1989, what is the difference between the Value added (in %) of Italy and Value added (in %) of Malawi?
Offer a terse response. 21.38. In the year 1989, what is the difference between the Value added (in %) of Italy and Value added (in %) of Malaysia?
Your answer should be compact. -11.68. In the year 1989, what is the difference between the Value added (in %) in Malawi and Value added (in %) in Malaysia?
Give a very brief answer. -33.06. In the year 1990, what is the difference between the Value added (in %) of Cyprus and Value added (in %) of Italy?
Offer a very short reply. -7.03. In the year 1990, what is the difference between the Value added (in %) of Cyprus and Value added (in %) of Malawi?
Offer a very short reply. 7.82. In the year 1990, what is the difference between the Value added (in %) in Cyprus and Value added (in %) in Malaysia?
Ensure brevity in your answer.  -19.53. In the year 1990, what is the difference between the Value added (in %) of Italy and Value added (in %) of Malawi?
Your answer should be very brief. 14.85. In the year 1990, what is the difference between the Value added (in %) in Italy and Value added (in %) in Malaysia?
Your answer should be compact. -12.5. In the year 1990, what is the difference between the Value added (in %) of Malawi and Value added (in %) of Malaysia?
Offer a very short reply. -27.35. In the year 1991, what is the difference between the Value added (in %) of Cyprus and Value added (in %) of Italy?
Your response must be concise. -6.56. In the year 1991, what is the difference between the Value added (in %) in Cyprus and Value added (in %) in Malawi?
Keep it short and to the point. 8.81. In the year 1991, what is the difference between the Value added (in %) in Cyprus and Value added (in %) in Malaysia?
Ensure brevity in your answer.  -19.1. In the year 1991, what is the difference between the Value added (in %) of Italy and Value added (in %) of Malawi?
Your response must be concise. 15.37. In the year 1991, what is the difference between the Value added (in %) in Italy and Value added (in %) in Malaysia?
Keep it short and to the point. -12.53. In the year 1991, what is the difference between the Value added (in %) of Malawi and Value added (in %) of Malaysia?
Your answer should be very brief. -27.9. What is the ratio of the Value added (in %) in Cyprus in 1984 to that in 1985?
Make the answer very short. 0.92. What is the ratio of the Value added (in %) in Italy in 1984 to that in 1985?
Give a very brief answer. 1.02. What is the ratio of the Value added (in %) of Malawi in 1984 to that in 1985?
Your answer should be compact. 0.56. What is the ratio of the Value added (in %) of Malaysia in 1984 to that in 1985?
Give a very brief answer. 0.99. What is the ratio of the Value added (in %) of Cyprus in 1984 to that in 1986?
Provide a succinct answer. 0.91. What is the ratio of the Value added (in %) of Italy in 1984 to that in 1986?
Provide a short and direct response. 1. What is the ratio of the Value added (in %) in Malawi in 1984 to that in 1986?
Keep it short and to the point. 1.04. What is the ratio of the Value added (in %) of Malaysia in 1984 to that in 1986?
Offer a terse response. 0.95. What is the ratio of the Value added (in %) of Cyprus in 1984 to that in 1987?
Ensure brevity in your answer.  0.94. What is the ratio of the Value added (in %) of Malawi in 1984 to that in 1987?
Ensure brevity in your answer.  0.85. What is the ratio of the Value added (in %) of Malaysia in 1984 to that in 1987?
Provide a short and direct response. 0.97. What is the ratio of the Value added (in %) of Cyprus in 1984 to that in 1988?
Your answer should be compact. 0.94. What is the ratio of the Value added (in %) of Italy in 1984 to that in 1988?
Give a very brief answer. 0.97. What is the ratio of the Value added (in %) in Malawi in 1984 to that in 1988?
Make the answer very short. 0.8. What is the ratio of the Value added (in %) of Malaysia in 1984 to that in 1988?
Make the answer very short. 0.94. What is the ratio of the Value added (in %) of Cyprus in 1984 to that in 1989?
Give a very brief answer. 0.92. What is the ratio of the Value added (in %) in Italy in 1984 to that in 1989?
Provide a short and direct response. 0.96. What is the ratio of the Value added (in %) in Malawi in 1984 to that in 1989?
Your answer should be compact. 0.76. What is the ratio of the Value added (in %) of Malaysia in 1984 to that in 1989?
Give a very brief answer. 0.88. What is the ratio of the Value added (in %) of Cyprus in 1984 to that in 1990?
Make the answer very short. 0.91. What is the ratio of the Value added (in %) in Italy in 1984 to that in 1990?
Provide a succinct answer. 0.94. What is the ratio of the Value added (in %) in Malawi in 1984 to that in 1990?
Provide a succinct answer. 0.58. What is the ratio of the Value added (in %) of Malaysia in 1984 to that in 1990?
Keep it short and to the point. 0.85. What is the ratio of the Value added (in %) in Cyprus in 1984 to that in 1991?
Provide a short and direct response. 0.9. What is the ratio of the Value added (in %) of Italy in 1984 to that in 1991?
Offer a terse response. 0.94. What is the ratio of the Value added (in %) of Malawi in 1984 to that in 1991?
Your answer should be very brief. 0.59. What is the ratio of the Value added (in %) in Malaysia in 1984 to that in 1991?
Offer a very short reply. 0.85. What is the ratio of the Value added (in %) in Cyprus in 1985 to that in 1986?
Ensure brevity in your answer.  0.98. What is the ratio of the Value added (in %) in Italy in 1985 to that in 1986?
Provide a succinct answer. 0.98. What is the ratio of the Value added (in %) of Malawi in 1985 to that in 1986?
Provide a succinct answer. 1.85. What is the ratio of the Value added (in %) in Malaysia in 1985 to that in 1986?
Offer a very short reply. 0.96. What is the ratio of the Value added (in %) in Cyprus in 1985 to that in 1987?
Make the answer very short. 1.02. What is the ratio of the Value added (in %) in Italy in 1985 to that in 1987?
Offer a very short reply. 0.99. What is the ratio of the Value added (in %) of Malawi in 1985 to that in 1987?
Provide a succinct answer. 1.52. What is the ratio of the Value added (in %) of Malaysia in 1985 to that in 1987?
Your response must be concise. 0.97. What is the ratio of the Value added (in %) of Cyprus in 1985 to that in 1988?
Provide a short and direct response. 1.02. What is the ratio of the Value added (in %) of Italy in 1985 to that in 1988?
Give a very brief answer. 0.95. What is the ratio of the Value added (in %) of Malawi in 1985 to that in 1988?
Provide a short and direct response. 1.42. What is the ratio of the Value added (in %) of Malaysia in 1985 to that in 1988?
Offer a very short reply. 0.95. What is the ratio of the Value added (in %) of Cyprus in 1985 to that in 1989?
Your answer should be compact. 1. What is the ratio of the Value added (in %) in Italy in 1985 to that in 1989?
Keep it short and to the point. 0.95. What is the ratio of the Value added (in %) of Malawi in 1985 to that in 1989?
Your response must be concise. 1.35. What is the ratio of the Value added (in %) of Malaysia in 1985 to that in 1989?
Ensure brevity in your answer.  0.89. What is the ratio of the Value added (in %) in Cyprus in 1985 to that in 1990?
Keep it short and to the point. 0.98. What is the ratio of the Value added (in %) of Italy in 1985 to that in 1990?
Provide a succinct answer. 0.92. What is the ratio of the Value added (in %) in Malawi in 1985 to that in 1990?
Your answer should be very brief. 1.03. What is the ratio of the Value added (in %) in Malaysia in 1985 to that in 1990?
Offer a very short reply. 0.86. What is the ratio of the Value added (in %) in Cyprus in 1985 to that in 1991?
Provide a succinct answer. 0.97. What is the ratio of the Value added (in %) in Italy in 1985 to that in 1991?
Your answer should be compact. 0.92. What is the ratio of the Value added (in %) in Malawi in 1985 to that in 1991?
Provide a short and direct response. 1.05. What is the ratio of the Value added (in %) in Malaysia in 1985 to that in 1991?
Your response must be concise. 0.86. What is the ratio of the Value added (in %) in Cyprus in 1986 to that in 1987?
Provide a succinct answer. 1.03. What is the ratio of the Value added (in %) in Malawi in 1986 to that in 1987?
Your answer should be very brief. 0.82. What is the ratio of the Value added (in %) of Malaysia in 1986 to that in 1987?
Your answer should be compact. 1.02. What is the ratio of the Value added (in %) of Cyprus in 1986 to that in 1988?
Give a very brief answer. 1.04. What is the ratio of the Value added (in %) of Italy in 1986 to that in 1988?
Offer a terse response. 0.97. What is the ratio of the Value added (in %) of Malawi in 1986 to that in 1988?
Provide a short and direct response. 0.77. What is the ratio of the Value added (in %) in Cyprus in 1986 to that in 1989?
Keep it short and to the point. 1.01. What is the ratio of the Value added (in %) in Italy in 1986 to that in 1989?
Ensure brevity in your answer.  0.96. What is the ratio of the Value added (in %) in Malawi in 1986 to that in 1989?
Make the answer very short. 0.73. What is the ratio of the Value added (in %) in Malaysia in 1986 to that in 1989?
Your response must be concise. 0.93. What is the ratio of the Value added (in %) in Cyprus in 1986 to that in 1990?
Provide a short and direct response. 1. What is the ratio of the Value added (in %) in Italy in 1986 to that in 1990?
Keep it short and to the point. 0.94. What is the ratio of the Value added (in %) in Malawi in 1986 to that in 1990?
Give a very brief answer. 0.56. What is the ratio of the Value added (in %) in Malaysia in 1986 to that in 1990?
Give a very brief answer. 0.9. What is the ratio of the Value added (in %) of Italy in 1986 to that in 1991?
Provide a succinct answer. 0.94. What is the ratio of the Value added (in %) in Malawi in 1986 to that in 1991?
Your answer should be compact. 0.57. What is the ratio of the Value added (in %) of Malaysia in 1986 to that in 1991?
Provide a short and direct response. 0.9. What is the ratio of the Value added (in %) in Italy in 1987 to that in 1988?
Keep it short and to the point. 0.97. What is the ratio of the Value added (in %) in Malawi in 1987 to that in 1988?
Your response must be concise. 0.93. What is the ratio of the Value added (in %) of Malaysia in 1987 to that in 1988?
Give a very brief answer. 0.98. What is the ratio of the Value added (in %) in Cyprus in 1987 to that in 1989?
Make the answer very short. 0.98. What is the ratio of the Value added (in %) in Italy in 1987 to that in 1989?
Offer a very short reply. 0.96. What is the ratio of the Value added (in %) in Malawi in 1987 to that in 1989?
Make the answer very short. 0.89. What is the ratio of the Value added (in %) of Malaysia in 1987 to that in 1989?
Keep it short and to the point. 0.91. What is the ratio of the Value added (in %) of Cyprus in 1987 to that in 1990?
Make the answer very short. 0.97. What is the ratio of the Value added (in %) in Italy in 1987 to that in 1990?
Your response must be concise. 0.94. What is the ratio of the Value added (in %) of Malawi in 1987 to that in 1990?
Your response must be concise. 0.68. What is the ratio of the Value added (in %) in Malaysia in 1987 to that in 1990?
Keep it short and to the point. 0.88. What is the ratio of the Value added (in %) of Cyprus in 1987 to that in 1991?
Provide a succinct answer. 0.96. What is the ratio of the Value added (in %) of Italy in 1987 to that in 1991?
Offer a very short reply. 0.94. What is the ratio of the Value added (in %) of Malawi in 1987 to that in 1991?
Your answer should be compact. 0.69. What is the ratio of the Value added (in %) of Malaysia in 1987 to that in 1991?
Give a very brief answer. 0.88. What is the ratio of the Value added (in %) in Cyprus in 1988 to that in 1989?
Give a very brief answer. 0.98. What is the ratio of the Value added (in %) in Malawi in 1988 to that in 1989?
Offer a terse response. 0.95. What is the ratio of the Value added (in %) of Malaysia in 1988 to that in 1989?
Offer a terse response. 0.93. What is the ratio of the Value added (in %) in Cyprus in 1988 to that in 1990?
Provide a short and direct response. 0.96. What is the ratio of the Value added (in %) in Italy in 1988 to that in 1990?
Your response must be concise. 0.97. What is the ratio of the Value added (in %) in Malawi in 1988 to that in 1990?
Your answer should be compact. 0.73. What is the ratio of the Value added (in %) of Malaysia in 1988 to that in 1990?
Your answer should be compact. 0.9. What is the ratio of the Value added (in %) in Cyprus in 1988 to that in 1991?
Give a very brief answer. 0.95. What is the ratio of the Value added (in %) in Italy in 1988 to that in 1991?
Your answer should be compact. 0.97. What is the ratio of the Value added (in %) of Malawi in 1988 to that in 1991?
Offer a very short reply. 0.74. What is the ratio of the Value added (in %) of Malaysia in 1988 to that in 1991?
Your response must be concise. 0.9. What is the ratio of the Value added (in %) of Cyprus in 1989 to that in 1990?
Your response must be concise. 0.99. What is the ratio of the Value added (in %) of Italy in 1989 to that in 1990?
Offer a very short reply. 0.98. What is the ratio of the Value added (in %) in Malawi in 1989 to that in 1990?
Offer a very short reply. 0.77. What is the ratio of the Value added (in %) of Malaysia in 1989 to that in 1990?
Keep it short and to the point. 0.97. What is the ratio of the Value added (in %) of Italy in 1989 to that in 1991?
Provide a short and direct response. 0.98. What is the ratio of the Value added (in %) in Malawi in 1989 to that in 1991?
Your answer should be very brief. 0.78. What is the ratio of the Value added (in %) in Malaysia in 1989 to that in 1991?
Provide a short and direct response. 0.97. What is the ratio of the Value added (in %) in Malawi in 1990 to that in 1991?
Ensure brevity in your answer.  1.02. What is the difference between the highest and the second highest Value added (in %) of Cyprus?
Make the answer very short. 0.43. What is the difference between the highest and the second highest Value added (in %) in Italy?
Your answer should be compact. 0.02. What is the difference between the highest and the second highest Value added (in %) in Malawi?
Provide a short and direct response. 1.14. What is the difference between the highest and the second highest Value added (in %) in Malaysia?
Give a very brief answer. 0.06. What is the difference between the highest and the lowest Value added (in %) in Cyprus?
Provide a succinct answer. 4.23. What is the difference between the highest and the lowest Value added (in %) of Italy?
Ensure brevity in your answer.  3.67. What is the difference between the highest and the lowest Value added (in %) of Malawi?
Offer a terse response. 15.63. What is the difference between the highest and the lowest Value added (in %) of Malaysia?
Make the answer very short. 8.96. 